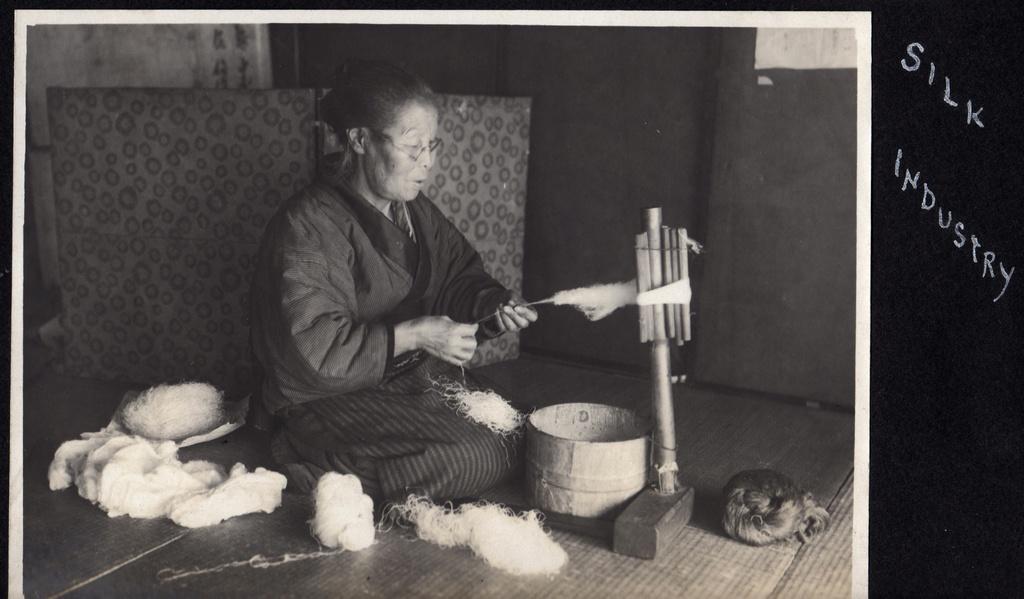How would you summarize this image in a sentence or two? There is a lady wearing specs and sitting on the floor and weaving threads using a machine. Near to her there is a basket. Also there are threads near to her. In the background there is a wall. On the right side there is something written on the black background. 